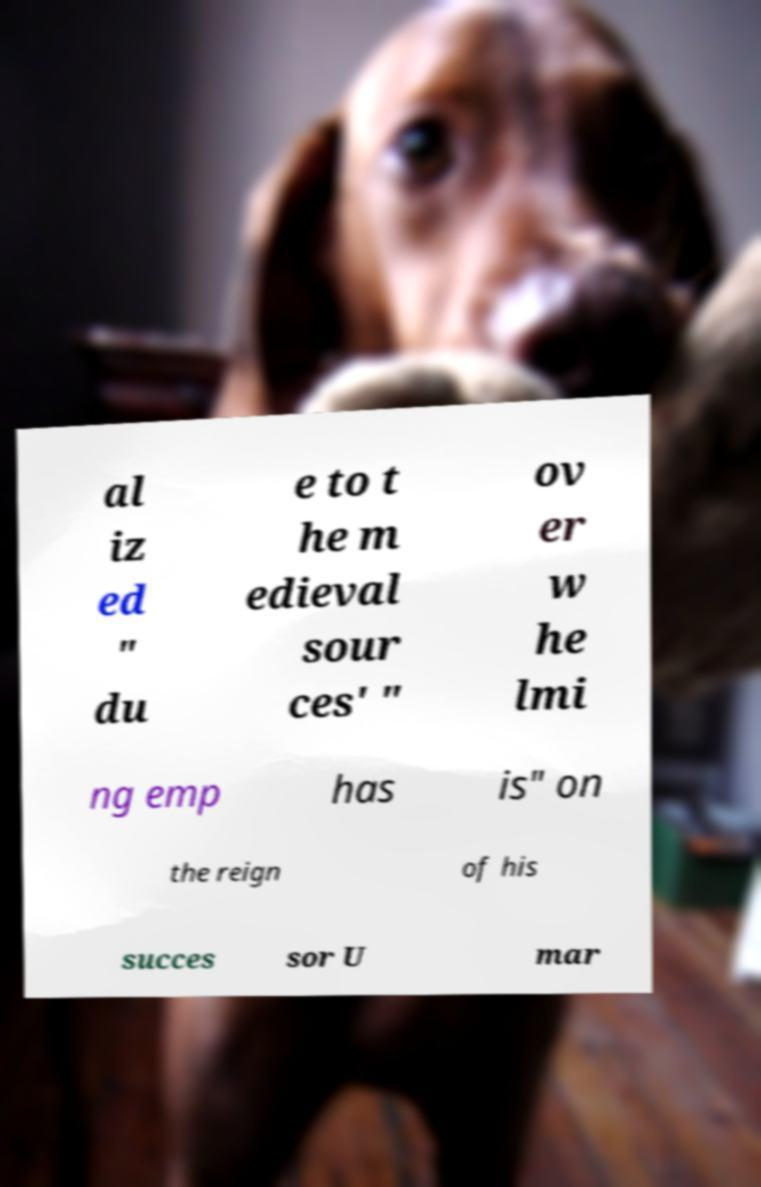What messages or text are displayed in this image? I need them in a readable, typed format. al iz ed " du e to t he m edieval sour ces' " ov er w he lmi ng emp has is" on the reign of his succes sor U mar 